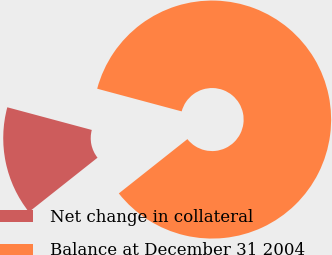Convert chart. <chart><loc_0><loc_0><loc_500><loc_500><pie_chart><fcel>Net change in collateral<fcel>Balance at December 31 2004<nl><fcel>14.83%<fcel>85.17%<nl></chart> 